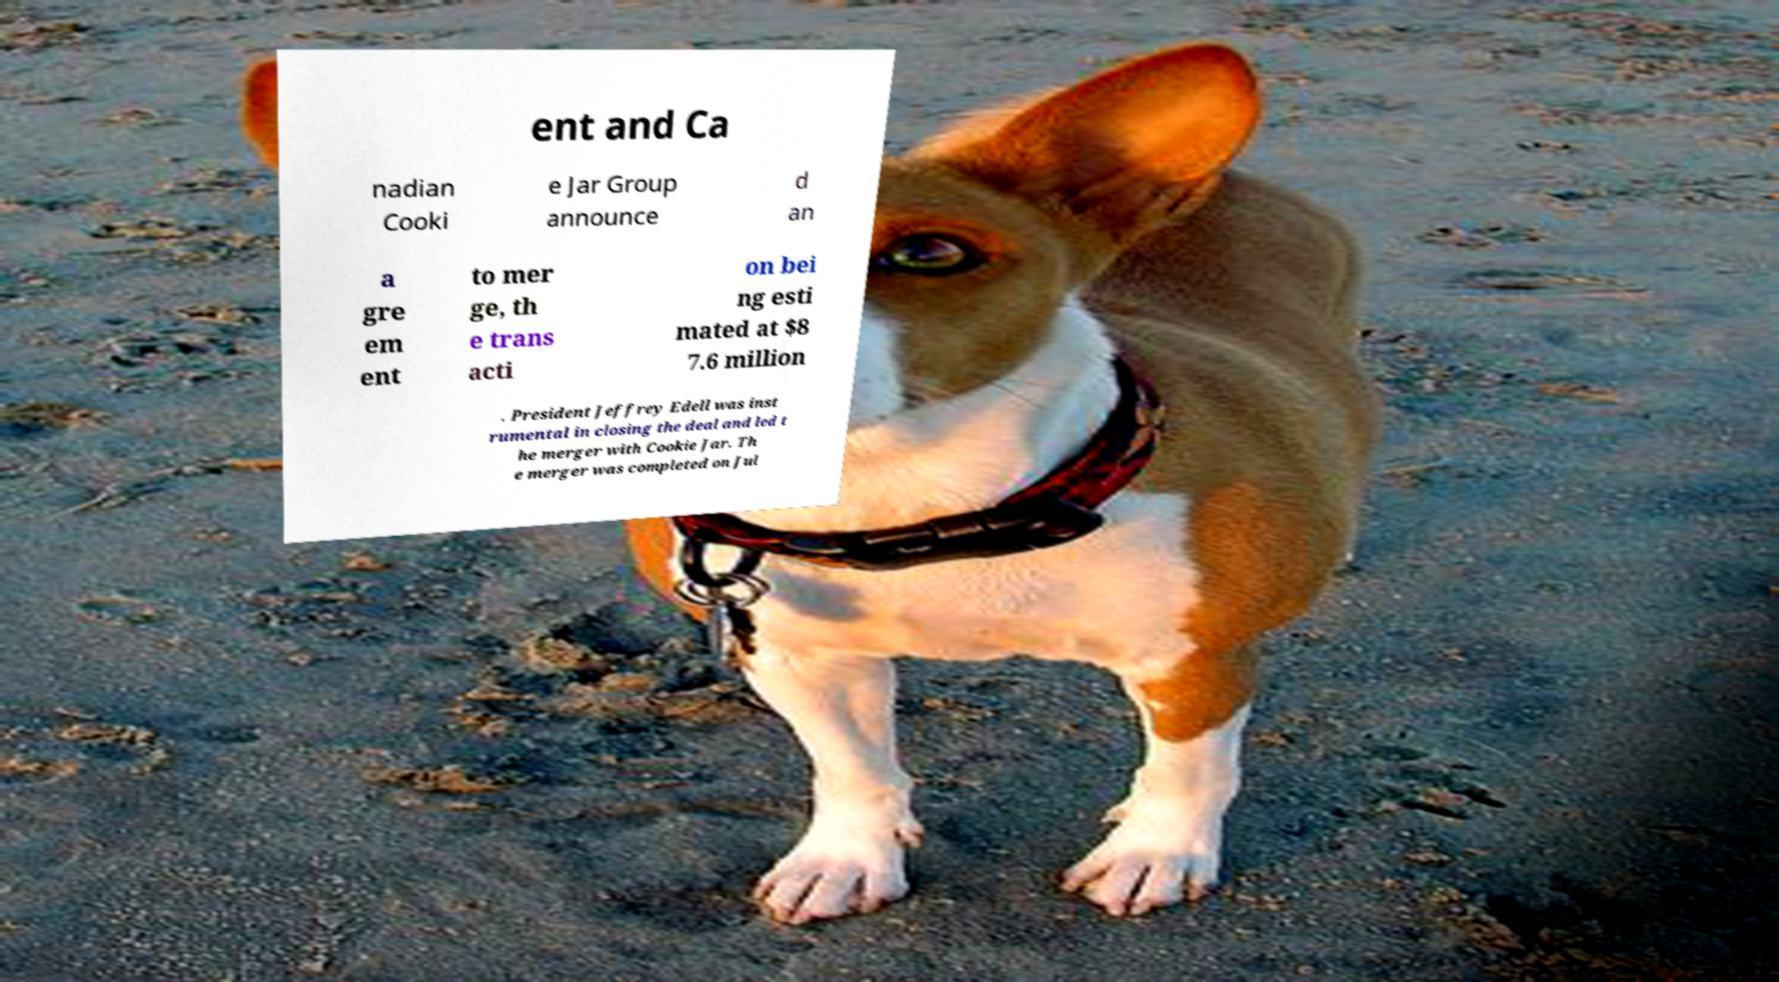What messages or text are displayed in this image? I need them in a readable, typed format. ent and Ca nadian Cooki e Jar Group announce d an a gre em ent to mer ge, th e trans acti on bei ng esti mated at $8 7.6 million . President Jeffrey Edell was inst rumental in closing the deal and led t he merger with Cookie Jar. Th e merger was completed on Jul 